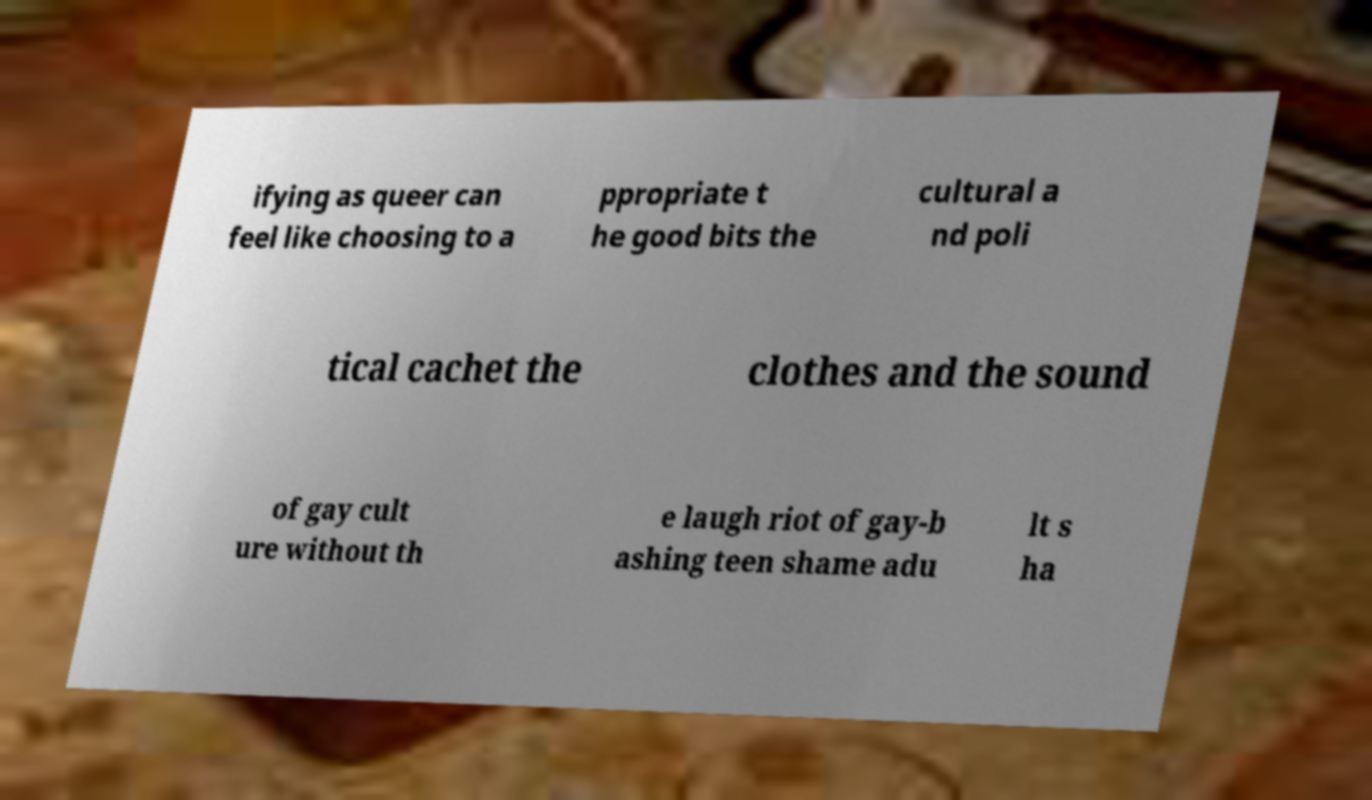Can you accurately transcribe the text from the provided image for me? ifying as queer can feel like choosing to a ppropriate t he good bits the cultural a nd poli tical cachet the clothes and the sound of gay cult ure without th e laugh riot of gay-b ashing teen shame adu lt s ha 